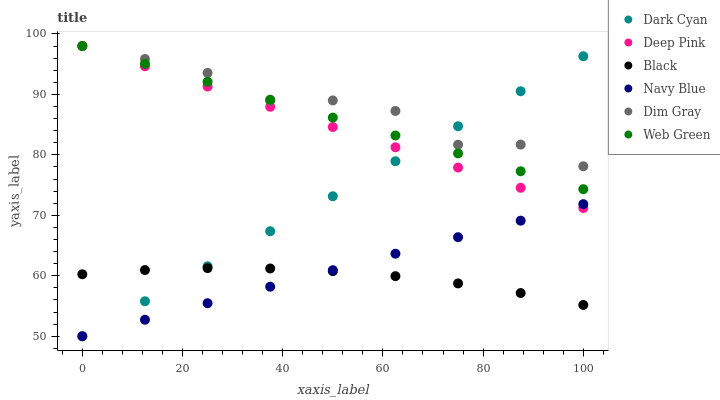Does Black have the minimum area under the curve?
Answer yes or no. Yes. Does Dim Gray have the maximum area under the curve?
Answer yes or no. Yes. Does Navy Blue have the minimum area under the curve?
Answer yes or no. No. Does Navy Blue have the maximum area under the curve?
Answer yes or no. No. Is Navy Blue the smoothest?
Answer yes or no. Yes. Is Dim Gray the roughest?
Answer yes or no. Yes. Is Web Green the smoothest?
Answer yes or no. No. Is Web Green the roughest?
Answer yes or no. No. Does Navy Blue have the lowest value?
Answer yes or no. Yes. Does Web Green have the lowest value?
Answer yes or no. No. Does Deep Pink have the highest value?
Answer yes or no. Yes. Does Navy Blue have the highest value?
Answer yes or no. No. Is Black less than Deep Pink?
Answer yes or no. Yes. Is Dim Gray greater than Black?
Answer yes or no. Yes. Does Dim Gray intersect Web Green?
Answer yes or no. Yes. Is Dim Gray less than Web Green?
Answer yes or no. No. Is Dim Gray greater than Web Green?
Answer yes or no. No. Does Black intersect Deep Pink?
Answer yes or no. No. 